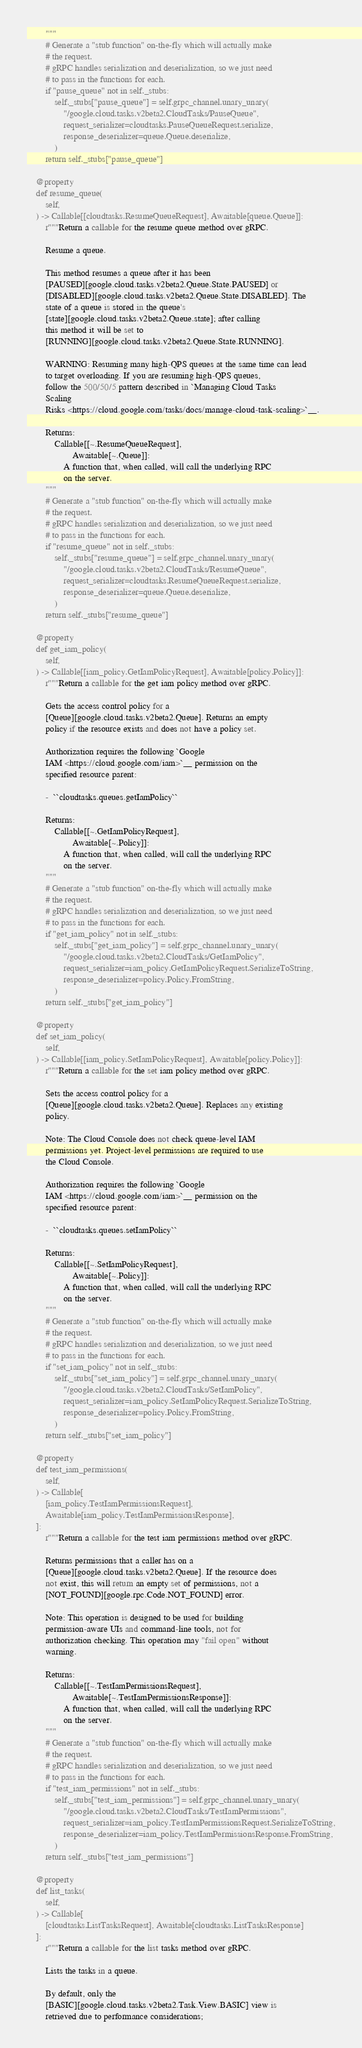<code> <loc_0><loc_0><loc_500><loc_500><_Python_>        """
        # Generate a "stub function" on-the-fly which will actually make
        # the request.
        # gRPC handles serialization and deserialization, so we just need
        # to pass in the functions for each.
        if "pause_queue" not in self._stubs:
            self._stubs["pause_queue"] = self.grpc_channel.unary_unary(
                "/google.cloud.tasks.v2beta2.CloudTasks/PauseQueue",
                request_serializer=cloudtasks.PauseQueueRequest.serialize,
                response_deserializer=queue.Queue.deserialize,
            )
        return self._stubs["pause_queue"]

    @property
    def resume_queue(
        self,
    ) -> Callable[[cloudtasks.ResumeQueueRequest], Awaitable[queue.Queue]]:
        r"""Return a callable for the resume queue method over gRPC.

        Resume a queue.

        This method resumes a queue after it has been
        [PAUSED][google.cloud.tasks.v2beta2.Queue.State.PAUSED] or
        [DISABLED][google.cloud.tasks.v2beta2.Queue.State.DISABLED]. The
        state of a queue is stored in the queue's
        [state][google.cloud.tasks.v2beta2.Queue.state]; after calling
        this method it will be set to
        [RUNNING][google.cloud.tasks.v2beta2.Queue.State.RUNNING].

        WARNING: Resuming many high-QPS queues at the same time can lead
        to target overloading. If you are resuming high-QPS queues,
        follow the 500/50/5 pattern described in `Managing Cloud Tasks
        Scaling
        Risks <https://cloud.google.com/tasks/docs/manage-cloud-task-scaling>`__.

        Returns:
            Callable[[~.ResumeQueueRequest],
                    Awaitable[~.Queue]]:
                A function that, when called, will call the underlying RPC
                on the server.
        """
        # Generate a "stub function" on-the-fly which will actually make
        # the request.
        # gRPC handles serialization and deserialization, so we just need
        # to pass in the functions for each.
        if "resume_queue" not in self._stubs:
            self._stubs["resume_queue"] = self.grpc_channel.unary_unary(
                "/google.cloud.tasks.v2beta2.CloudTasks/ResumeQueue",
                request_serializer=cloudtasks.ResumeQueueRequest.serialize,
                response_deserializer=queue.Queue.deserialize,
            )
        return self._stubs["resume_queue"]

    @property
    def get_iam_policy(
        self,
    ) -> Callable[[iam_policy.GetIamPolicyRequest], Awaitable[policy.Policy]]:
        r"""Return a callable for the get iam policy method over gRPC.

        Gets the access control policy for a
        [Queue][google.cloud.tasks.v2beta2.Queue]. Returns an empty
        policy if the resource exists and does not have a policy set.

        Authorization requires the following `Google
        IAM <https://cloud.google.com/iam>`__ permission on the
        specified resource parent:

        -  ``cloudtasks.queues.getIamPolicy``

        Returns:
            Callable[[~.GetIamPolicyRequest],
                    Awaitable[~.Policy]]:
                A function that, when called, will call the underlying RPC
                on the server.
        """
        # Generate a "stub function" on-the-fly which will actually make
        # the request.
        # gRPC handles serialization and deserialization, so we just need
        # to pass in the functions for each.
        if "get_iam_policy" not in self._stubs:
            self._stubs["get_iam_policy"] = self.grpc_channel.unary_unary(
                "/google.cloud.tasks.v2beta2.CloudTasks/GetIamPolicy",
                request_serializer=iam_policy.GetIamPolicyRequest.SerializeToString,
                response_deserializer=policy.Policy.FromString,
            )
        return self._stubs["get_iam_policy"]

    @property
    def set_iam_policy(
        self,
    ) -> Callable[[iam_policy.SetIamPolicyRequest], Awaitable[policy.Policy]]:
        r"""Return a callable for the set iam policy method over gRPC.

        Sets the access control policy for a
        [Queue][google.cloud.tasks.v2beta2.Queue]. Replaces any existing
        policy.

        Note: The Cloud Console does not check queue-level IAM
        permissions yet. Project-level permissions are required to use
        the Cloud Console.

        Authorization requires the following `Google
        IAM <https://cloud.google.com/iam>`__ permission on the
        specified resource parent:

        -  ``cloudtasks.queues.setIamPolicy``

        Returns:
            Callable[[~.SetIamPolicyRequest],
                    Awaitable[~.Policy]]:
                A function that, when called, will call the underlying RPC
                on the server.
        """
        # Generate a "stub function" on-the-fly which will actually make
        # the request.
        # gRPC handles serialization and deserialization, so we just need
        # to pass in the functions for each.
        if "set_iam_policy" not in self._stubs:
            self._stubs["set_iam_policy"] = self.grpc_channel.unary_unary(
                "/google.cloud.tasks.v2beta2.CloudTasks/SetIamPolicy",
                request_serializer=iam_policy.SetIamPolicyRequest.SerializeToString,
                response_deserializer=policy.Policy.FromString,
            )
        return self._stubs["set_iam_policy"]

    @property
    def test_iam_permissions(
        self,
    ) -> Callable[
        [iam_policy.TestIamPermissionsRequest],
        Awaitable[iam_policy.TestIamPermissionsResponse],
    ]:
        r"""Return a callable for the test iam permissions method over gRPC.

        Returns permissions that a caller has on a
        [Queue][google.cloud.tasks.v2beta2.Queue]. If the resource does
        not exist, this will return an empty set of permissions, not a
        [NOT_FOUND][google.rpc.Code.NOT_FOUND] error.

        Note: This operation is designed to be used for building
        permission-aware UIs and command-line tools, not for
        authorization checking. This operation may "fail open" without
        warning.

        Returns:
            Callable[[~.TestIamPermissionsRequest],
                    Awaitable[~.TestIamPermissionsResponse]]:
                A function that, when called, will call the underlying RPC
                on the server.
        """
        # Generate a "stub function" on-the-fly which will actually make
        # the request.
        # gRPC handles serialization and deserialization, so we just need
        # to pass in the functions for each.
        if "test_iam_permissions" not in self._stubs:
            self._stubs["test_iam_permissions"] = self.grpc_channel.unary_unary(
                "/google.cloud.tasks.v2beta2.CloudTasks/TestIamPermissions",
                request_serializer=iam_policy.TestIamPermissionsRequest.SerializeToString,
                response_deserializer=iam_policy.TestIamPermissionsResponse.FromString,
            )
        return self._stubs["test_iam_permissions"]

    @property
    def list_tasks(
        self,
    ) -> Callable[
        [cloudtasks.ListTasksRequest], Awaitable[cloudtasks.ListTasksResponse]
    ]:
        r"""Return a callable for the list tasks method over gRPC.

        Lists the tasks in a queue.

        By default, only the
        [BASIC][google.cloud.tasks.v2beta2.Task.View.BASIC] view is
        retrieved due to performance considerations;</code> 